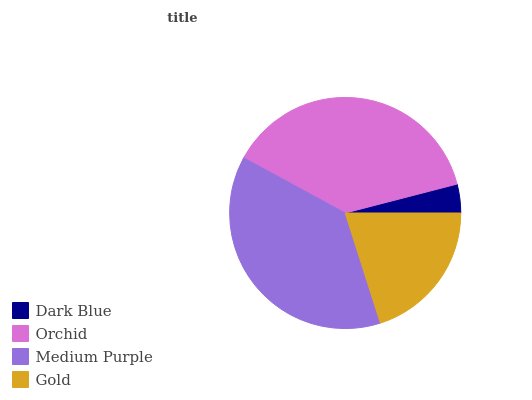Is Dark Blue the minimum?
Answer yes or no. Yes. Is Orchid the maximum?
Answer yes or no. Yes. Is Medium Purple the minimum?
Answer yes or no. No. Is Medium Purple the maximum?
Answer yes or no. No. Is Orchid greater than Medium Purple?
Answer yes or no. Yes. Is Medium Purple less than Orchid?
Answer yes or no. Yes. Is Medium Purple greater than Orchid?
Answer yes or no. No. Is Orchid less than Medium Purple?
Answer yes or no. No. Is Medium Purple the high median?
Answer yes or no. Yes. Is Gold the low median?
Answer yes or no. Yes. Is Orchid the high median?
Answer yes or no. No. Is Orchid the low median?
Answer yes or no. No. 